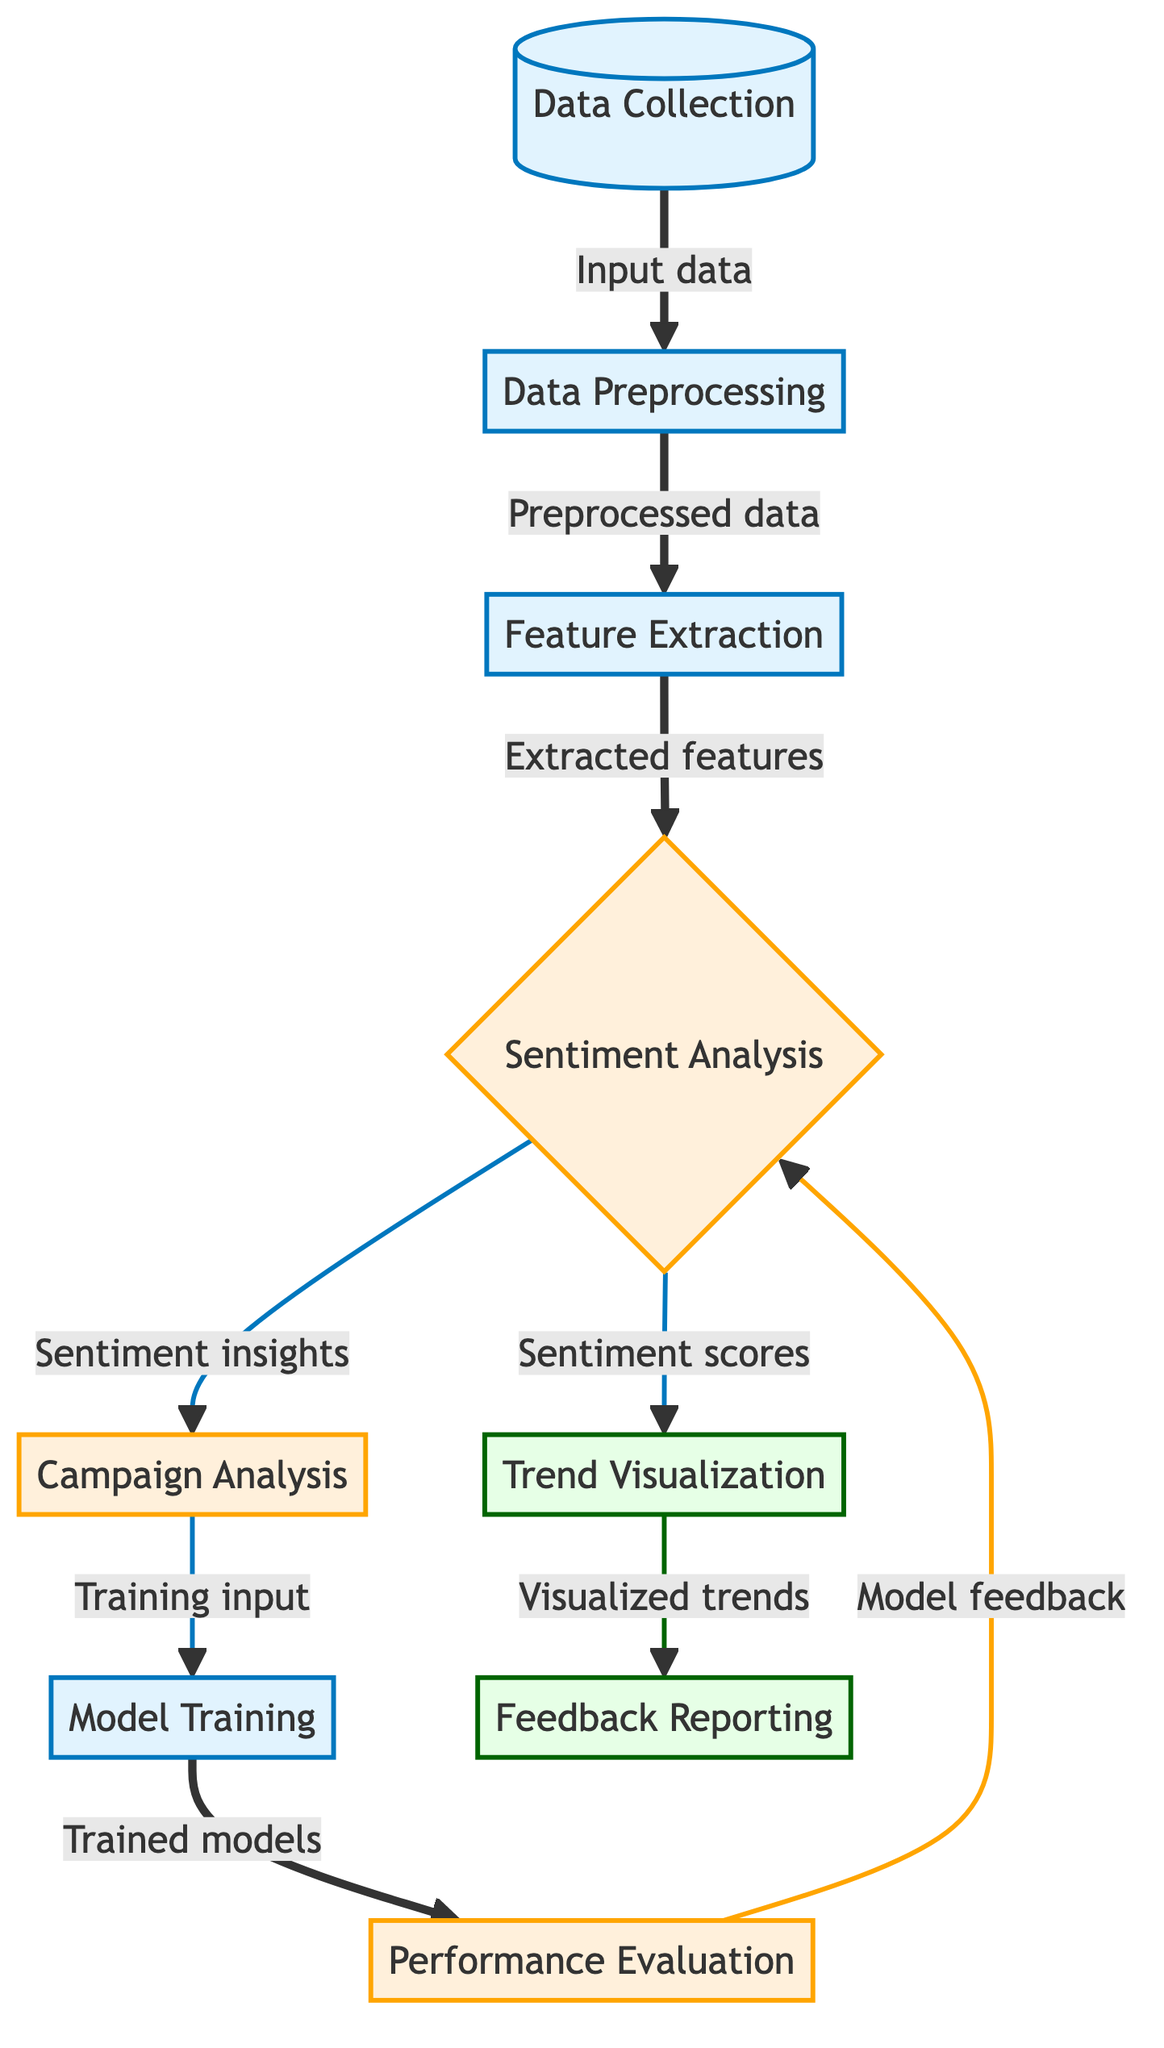What is the first process in the diagram? The first process node in the diagram, labeled "Data Collection," clearly indicates the starting point of the flowchart.
Answer: Data Collection How many analysis nodes are in the diagram? By counting the nodes labeled with the "analysis" class, we find two nodes: "Sentiment Analysis" and "Campaign Analysis."
Answer: 2 What is the output of the "Sentiment Analysis" node? The "Sentiment Analysis" node produces two outputs labeled "Sentiment scores" and "Sentiment insights," both leading to different follow-up processes.
Answer: Sentiment scores and Sentiment insights Which node follows "Feature Extraction"? The diagram indicates that "Feature Extraction" leads directly to the "Sentiment Analysis" node. Thus, "Sentiment Analysis" is the next step.
Answer: Sentiment Analysis What type of node is "Model Training"? The node "Model Training" is categorized as a process, defined in the diagram with a specific fill color and stroke style.
Answer: Process What are the outputs generated after "Trend Visualization"? According to the diagram, "Trend Visualization" produces the output labeled "Feedback Reporting."
Answer: Feedback Reporting What node is connected directly to "Performance Evaluation"? The "Performance Evaluation" node has a direct connection going back to the "Sentiment Analysis" node, indicating its role in the feedback loop.
Answer: Sentiment Analysis What type of diagram is presented here? The flowchart specifically represents a machine learning process aimed at visualizing customer sentiment analysis related to Olympus.
Answer: Machine Learning Diagram What is the relationship between "Data Preprocessing" and "Feature Extraction"? "Data Preprocessing" serves as an input to "Feature Extraction," indicating that preprocessed data is needed to extract relevant features.
Answer: Input-output relationship 